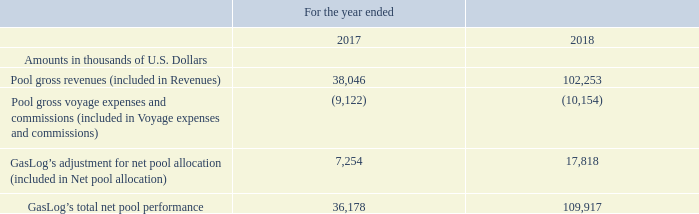Net Pool Allocation: Net pool allocation increased by $10.5 million, from $7.3 million during the year ended December 31, 2017 to $17.8 million during the year ended December 31, 2018. The increase in net pool allocation was attributable to the movement in the adjustment of the net pool results earned by the GasLog vessels in accordance with the pool distribution formula. GasLog recognized gross revenues and gross voyage expenses and commissions of $102.3 million and $10.2 million, respectively, from the operation of its vessels in the Cool Pool during the year ended December 31, 2018 (December 31, 2017: $38.0 million and $9.1 million, respectively). The increase in GasLog’s total net pool performance was driven by higher spot rates and higher utilization achieved by all vessels trading in the Cool Pool. GasLog’s total net pool performance is presented below:
Voyage Expenses and Commissions: Voyage expenses and commissions increased by 32.5%, or $5.0 million, from $15.4 million during the year ended December 31, 2017 to $20.4 million during the year ended December 31, 2018. The increase in voyage expenses and commissions is mainly attributable to an increase of $3.6 million in bunkers consumed and voyage expenses during certain unchartered and off-hire periods, an increase of $0.3 million in voyage expenses of the vessels operating in the spot market and an increase of $1.1 million in brokers’ commissions.
In which years was the total net pool performance recorded for? 2018, 2017. What accounted for the increase in net pool allocation? Attributable to the movement in the adjustment of the net pool results earned by the gaslog vessels in accordance with the pool distribution formula. What accounted for the increase in voyage expenses and commissions? Mainly attributable to an increase of $3.6 million in bunkers consumed and voyage expenses during certain unchartered and off-hire periods, an increase of $0.3 million in voyage expenses of the vessels operating in the spot market and an increase of $1.1 million in brokers’ commissions. Which year was the pool gross revenues higher? 102,253 > 38,046
Answer: 2018. What is the change in pool gross revenues from 2017 to 2018?
Answer scale should be: thousand. 102,253 - 38,046 
Answer: 64207. What is the percentage change in total net pool performance from 2017 to 2018?
Answer scale should be: percent. (109,917 - 36,178)/36,178 
Answer: 203.82. 